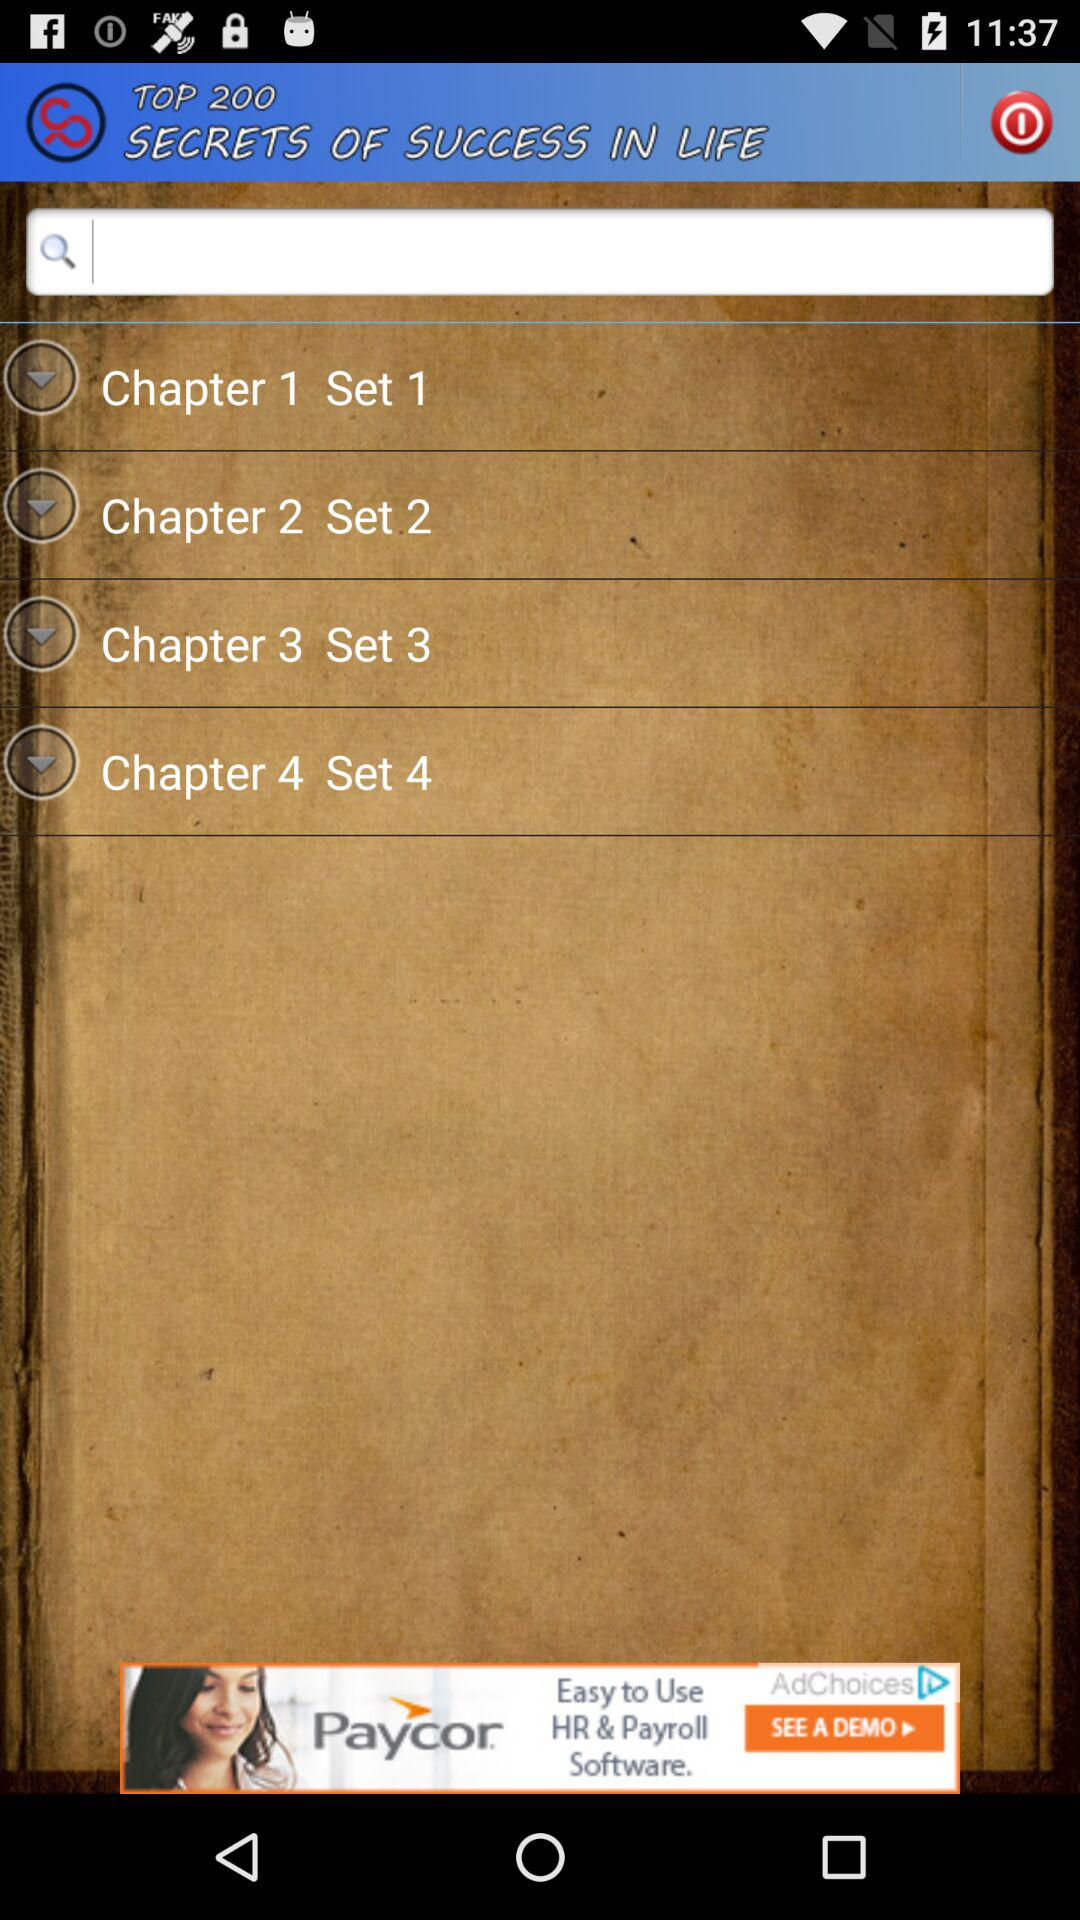Is "Chapter 3 Set 3" checked or unchecked?
When the provided information is insufficient, respond with <no answer>. <no answer> 